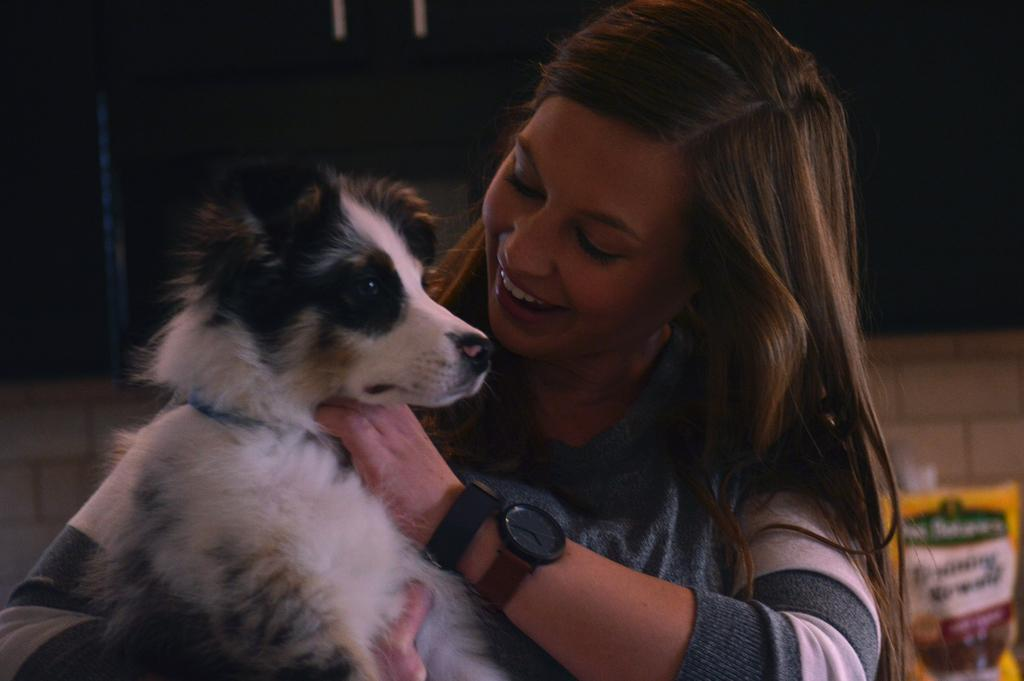What is the woman holding in the image? The woman is holding a dog. What design is featured on the dog's collar in the image? There is no information about the dog's collar in the provided facts, so we cannot determine the design. --- Facts: 1. There is a man standing near a car. 2. The car is red in color. Absurd Topics: move, walk, crib Conversation: What is the man doing in the image? The man is standing near a car. What color is the car in the image? The car is red in color. Reasoning: Let's think step by step in order to produce the conversation. We start by identifying the main subjects and objects in the image based on the provided facts. We then formulate questions that focus on the location and characteristics of these subjects and objects, ensuring that each question can be answered definitively with the information given. We avoid yes/no questions and ensure that the language is simple and clear. Absurd Question/Answer: How does the man move around the car in the image? The provided facts do not mention the man's movement around the car, so we cannot determine how he moves. --- Facts: 1. There is a group of people sitting around a table. 2. They are having a meal. Absurd Topics: design, month, tree Conversation: What are the people in the image doing? The people are sitting around a table and having a meal. Reasoning: Let's think step by step in order to produce the conversation. We start by identifying the main subjects and objects in the image based on the provided facts. We then formulate questions that focus on the location and characteristics of these subjects and objects, ensuring that each question can be answered definitively with the information given. We avoid yes/no questions and ensure that the language is simple and clear. Absurd Question/Answer: What design is featured on the tablecloth in the image? There is no information about a tablecloth in the provided facts, so we cannot determine the design. --- Facts: 1. There is a cat sitting on a chair. 2. The chair is made of wood. Absurd Topics: move, walk, crib Conversation: What is the cat doing in the image? The cat is sitting on a chair. What is the chair made of in the image? The chair is made of wood. Reasoning: Let's think step by step in order to produce the conversation. We start by identifying the main subjects and objects in the image based on the provided facts. We then formulate questions that focus on the location and characteristics of these subjects and objects, ensuring that each question can be answered definitively with the information given. We avoid yes/no questions and ensure that the language is simple and clear. 